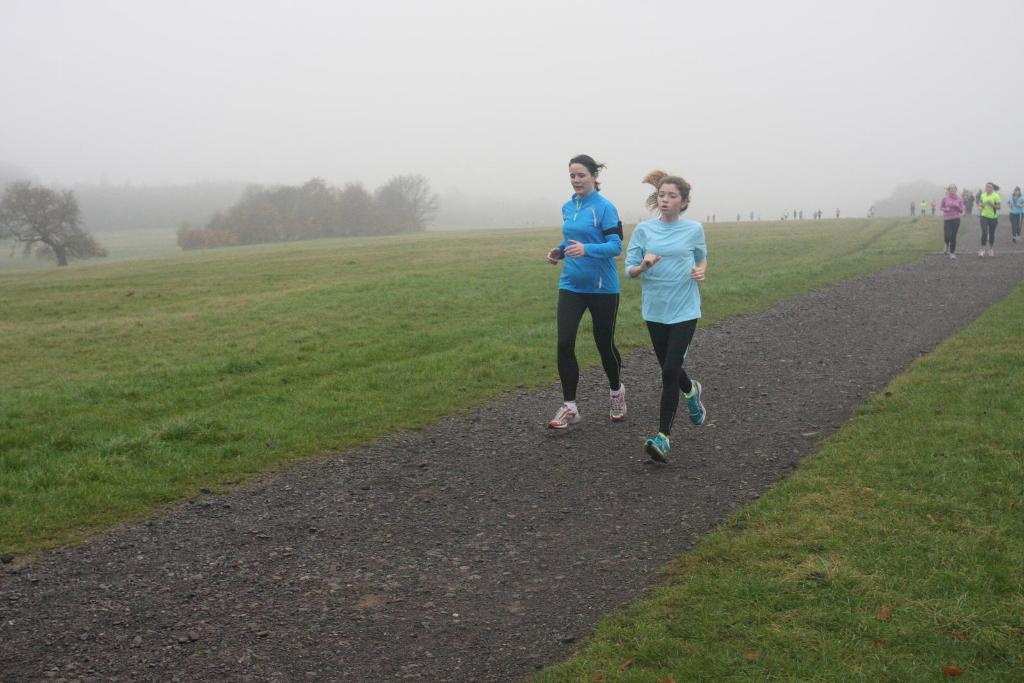What are the people in the image doing? The people in the image are running on the ground. What type of vegetation can be seen in the image? There are trees and grass in the image. What is visible in the background of the image? The sky is visible in the image. What type of mask is being worn by the people in the image? There is no mask visible in the image; the people are running without any masks. Can you tell me how many beans are present in the image? There are no beans present in the image. 